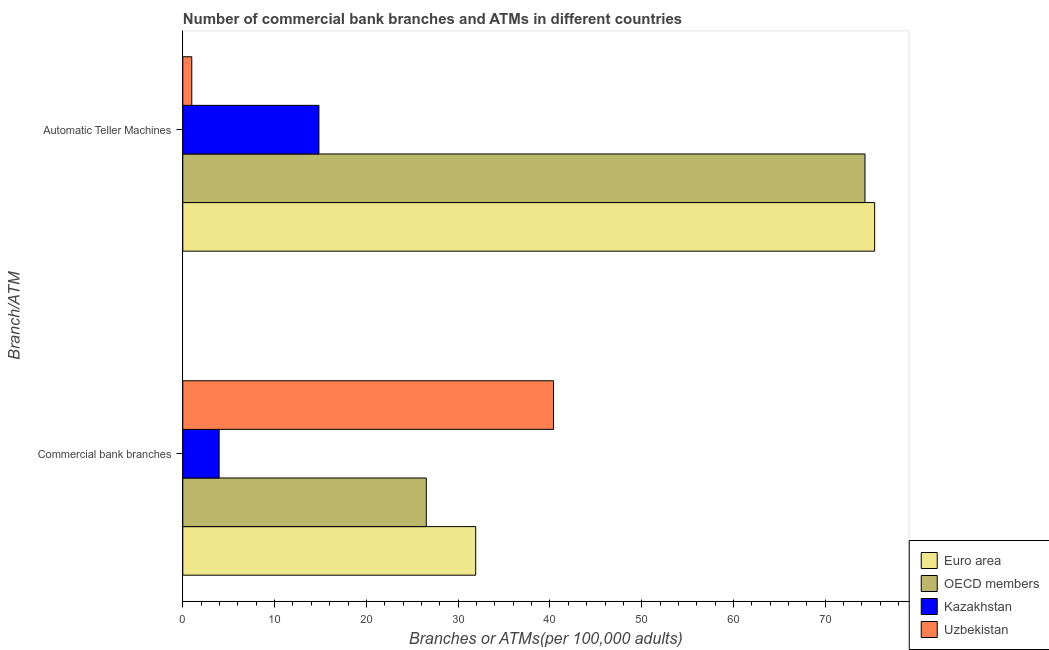What is the label of the 2nd group of bars from the top?
Your answer should be very brief. Commercial bank branches. What is the number of atms in Kazakhstan?
Offer a terse response. 14.83. Across all countries, what is the maximum number of atms?
Give a very brief answer. 75.38. Across all countries, what is the minimum number of commercal bank branches?
Your answer should be very brief. 3.96. In which country was the number of commercal bank branches maximum?
Give a very brief answer. Uzbekistan. In which country was the number of atms minimum?
Give a very brief answer. Uzbekistan. What is the total number of atms in the graph?
Your response must be concise. 165.51. What is the difference between the number of commercal bank branches in Euro area and that in OECD members?
Your answer should be very brief. 5.38. What is the difference between the number of atms in OECD members and the number of commercal bank branches in Uzbekistan?
Ensure brevity in your answer.  33.93. What is the average number of atms per country?
Keep it short and to the point. 41.38. What is the difference between the number of commercal bank branches and number of atms in Uzbekistan?
Offer a terse response. 39.42. In how many countries, is the number of commercal bank branches greater than 20 ?
Give a very brief answer. 3. What is the ratio of the number of atms in Uzbekistan to that in OECD members?
Give a very brief answer. 0.01. Is the number of commercal bank branches in OECD members less than that in Kazakhstan?
Make the answer very short. No. In how many countries, is the number of atms greater than the average number of atms taken over all countries?
Offer a terse response. 2. What does the 1st bar from the top in Automatic Teller Machines represents?
Your answer should be compact. Uzbekistan. What does the 4th bar from the bottom in Automatic Teller Machines represents?
Your response must be concise. Uzbekistan. Are all the bars in the graph horizontal?
Offer a very short reply. Yes. Are the values on the major ticks of X-axis written in scientific E-notation?
Offer a very short reply. No. Does the graph contain grids?
Give a very brief answer. No. How many legend labels are there?
Offer a very short reply. 4. How are the legend labels stacked?
Your response must be concise. Vertical. What is the title of the graph?
Make the answer very short. Number of commercial bank branches and ATMs in different countries. What is the label or title of the X-axis?
Your answer should be compact. Branches or ATMs(per 100,0 adults). What is the label or title of the Y-axis?
Offer a terse response. Branch/ATM. What is the Branches or ATMs(per 100,000 adults) of Euro area in Commercial bank branches?
Make the answer very short. 31.92. What is the Branches or ATMs(per 100,000 adults) in OECD members in Commercial bank branches?
Provide a short and direct response. 26.53. What is the Branches or ATMs(per 100,000 adults) of Kazakhstan in Commercial bank branches?
Provide a succinct answer. 3.96. What is the Branches or ATMs(per 100,000 adults) of Uzbekistan in Commercial bank branches?
Offer a very short reply. 40.4. What is the Branches or ATMs(per 100,000 adults) of Euro area in Automatic Teller Machines?
Your answer should be compact. 75.38. What is the Branches or ATMs(per 100,000 adults) of OECD members in Automatic Teller Machines?
Offer a very short reply. 74.33. What is the Branches or ATMs(per 100,000 adults) of Kazakhstan in Automatic Teller Machines?
Your answer should be very brief. 14.83. What is the Branches or ATMs(per 100,000 adults) in Uzbekistan in Automatic Teller Machines?
Offer a very short reply. 0.98. Across all Branch/ATM, what is the maximum Branches or ATMs(per 100,000 adults) of Euro area?
Provide a succinct answer. 75.38. Across all Branch/ATM, what is the maximum Branches or ATMs(per 100,000 adults) in OECD members?
Provide a succinct answer. 74.33. Across all Branch/ATM, what is the maximum Branches or ATMs(per 100,000 adults) of Kazakhstan?
Provide a succinct answer. 14.83. Across all Branch/ATM, what is the maximum Branches or ATMs(per 100,000 adults) in Uzbekistan?
Your response must be concise. 40.4. Across all Branch/ATM, what is the minimum Branches or ATMs(per 100,000 adults) of Euro area?
Ensure brevity in your answer.  31.92. Across all Branch/ATM, what is the minimum Branches or ATMs(per 100,000 adults) of OECD members?
Provide a short and direct response. 26.53. Across all Branch/ATM, what is the minimum Branches or ATMs(per 100,000 adults) in Kazakhstan?
Give a very brief answer. 3.96. Across all Branch/ATM, what is the minimum Branches or ATMs(per 100,000 adults) of Uzbekistan?
Offer a very short reply. 0.98. What is the total Branches or ATMs(per 100,000 adults) of Euro area in the graph?
Offer a very short reply. 107.29. What is the total Branches or ATMs(per 100,000 adults) of OECD members in the graph?
Offer a very short reply. 100.86. What is the total Branches or ATMs(per 100,000 adults) in Kazakhstan in the graph?
Your response must be concise. 18.79. What is the total Branches or ATMs(per 100,000 adults) of Uzbekistan in the graph?
Your answer should be very brief. 41.37. What is the difference between the Branches or ATMs(per 100,000 adults) of Euro area in Commercial bank branches and that in Automatic Teller Machines?
Your response must be concise. -43.46. What is the difference between the Branches or ATMs(per 100,000 adults) in OECD members in Commercial bank branches and that in Automatic Teller Machines?
Provide a short and direct response. -47.8. What is the difference between the Branches or ATMs(per 100,000 adults) in Kazakhstan in Commercial bank branches and that in Automatic Teller Machines?
Give a very brief answer. -10.87. What is the difference between the Branches or ATMs(per 100,000 adults) of Uzbekistan in Commercial bank branches and that in Automatic Teller Machines?
Your answer should be compact. 39.42. What is the difference between the Branches or ATMs(per 100,000 adults) in Euro area in Commercial bank branches and the Branches or ATMs(per 100,000 adults) in OECD members in Automatic Teller Machines?
Provide a succinct answer. -42.41. What is the difference between the Branches or ATMs(per 100,000 adults) in Euro area in Commercial bank branches and the Branches or ATMs(per 100,000 adults) in Kazakhstan in Automatic Teller Machines?
Your response must be concise. 17.08. What is the difference between the Branches or ATMs(per 100,000 adults) of Euro area in Commercial bank branches and the Branches or ATMs(per 100,000 adults) of Uzbekistan in Automatic Teller Machines?
Offer a terse response. 30.94. What is the difference between the Branches or ATMs(per 100,000 adults) of OECD members in Commercial bank branches and the Branches or ATMs(per 100,000 adults) of Kazakhstan in Automatic Teller Machines?
Provide a short and direct response. 11.7. What is the difference between the Branches or ATMs(per 100,000 adults) in OECD members in Commercial bank branches and the Branches or ATMs(per 100,000 adults) in Uzbekistan in Automatic Teller Machines?
Provide a succinct answer. 25.55. What is the difference between the Branches or ATMs(per 100,000 adults) in Kazakhstan in Commercial bank branches and the Branches or ATMs(per 100,000 adults) in Uzbekistan in Automatic Teller Machines?
Your answer should be very brief. 2.98. What is the average Branches or ATMs(per 100,000 adults) of Euro area per Branch/ATM?
Provide a succinct answer. 53.65. What is the average Branches or ATMs(per 100,000 adults) in OECD members per Branch/ATM?
Ensure brevity in your answer.  50.43. What is the average Branches or ATMs(per 100,000 adults) in Kazakhstan per Branch/ATM?
Ensure brevity in your answer.  9.4. What is the average Branches or ATMs(per 100,000 adults) in Uzbekistan per Branch/ATM?
Offer a terse response. 20.69. What is the difference between the Branches or ATMs(per 100,000 adults) in Euro area and Branches or ATMs(per 100,000 adults) in OECD members in Commercial bank branches?
Your response must be concise. 5.38. What is the difference between the Branches or ATMs(per 100,000 adults) of Euro area and Branches or ATMs(per 100,000 adults) of Kazakhstan in Commercial bank branches?
Your response must be concise. 27.95. What is the difference between the Branches or ATMs(per 100,000 adults) in Euro area and Branches or ATMs(per 100,000 adults) in Uzbekistan in Commercial bank branches?
Your answer should be very brief. -8.48. What is the difference between the Branches or ATMs(per 100,000 adults) in OECD members and Branches or ATMs(per 100,000 adults) in Kazakhstan in Commercial bank branches?
Ensure brevity in your answer.  22.57. What is the difference between the Branches or ATMs(per 100,000 adults) of OECD members and Branches or ATMs(per 100,000 adults) of Uzbekistan in Commercial bank branches?
Your answer should be compact. -13.86. What is the difference between the Branches or ATMs(per 100,000 adults) in Kazakhstan and Branches or ATMs(per 100,000 adults) in Uzbekistan in Commercial bank branches?
Your answer should be compact. -36.43. What is the difference between the Branches or ATMs(per 100,000 adults) in Euro area and Branches or ATMs(per 100,000 adults) in OECD members in Automatic Teller Machines?
Your answer should be very brief. 1.05. What is the difference between the Branches or ATMs(per 100,000 adults) of Euro area and Branches or ATMs(per 100,000 adults) of Kazakhstan in Automatic Teller Machines?
Provide a succinct answer. 60.55. What is the difference between the Branches or ATMs(per 100,000 adults) of Euro area and Branches or ATMs(per 100,000 adults) of Uzbekistan in Automatic Teller Machines?
Provide a short and direct response. 74.4. What is the difference between the Branches or ATMs(per 100,000 adults) of OECD members and Branches or ATMs(per 100,000 adults) of Kazakhstan in Automatic Teller Machines?
Make the answer very short. 59.5. What is the difference between the Branches or ATMs(per 100,000 adults) in OECD members and Branches or ATMs(per 100,000 adults) in Uzbekistan in Automatic Teller Machines?
Your answer should be compact. 73.35. What is the difference between the Branches or ATMs(per 100,000 adults) in Kazakhstan and Branches or ATMs(per 100,000 adults) in Uzbekistan in Automatic Teller Machines?
Provide a short and direct response. 13.85. What is the ratio of the Branches or ATMs(per 100,000 adults) of Euro area in Commercial bank branches to that in Automatic Teller Machines?
Offer a terse response. 0.42. What is the ratio of the Branches or ATMs(per 100,000 adults) in OECD members in Commercial bank branches to that in Automatic Teller Machines?
Your answer should be compact. 0.36. What is the ratio of the Branches or ATMs(per 100,000 adults) in Kazakhstan in Commercial bank branches to that in Automatic Teller Machines?
Keep it short and to the point. 0.27. What is the ratio of the Branches or ATMs(per 100,000 adults) of Uzbekistan in Commercial bank branches to that in Automatic Teller Machines?
Your response must be concise. 41.27. What is the difference between the highest and the second highest Branches or ATMs(per 100,000 adults) of Euro area?
Make the answer very short. 43.46. What is the difference between the highest and the second highest Branches or ATMs(per 100,000 adults) in OECD members?
Provide a succinct answer. 47.8. What is the difference between the highest and the second highest Branches or ATMs(per 100,000 adults) of Kazakhstan?
Offer a terse response. 10.87. What is the difference between the highest and the second highest Branches or ATMs(per 100,000 adults) in Uzbekistan?
Offer a terse response. 39.42. What is the difference between the highest and the lowest Branches or ATMs(per 100,000 adults) of Euro area?
Give a very brief answer. 43.46. What is the difference between the highest and the lowest Branches or ATMs(per 100,000 adults) of OECD members?
Your answer should be very brief. 47.8. What is the difference between the highest and the lowest Branches or ATMs(per 100,000 adults) in Kazakhstan?
Offer a very short reply. 10.87. What is the difference between the highest and the lowest Branches or ATMs(per 100,000 adults) in Uzbekistan?
Offer a very short reply. 39.42. 